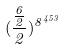Convert formula to latex. <formula><loc_0><loc_0><loc_500><loc_500>( \frac { \frac { 6 } { 2 } } { 2 } ) ^ { 8 ^ { 4 5 3 } }</formula> 